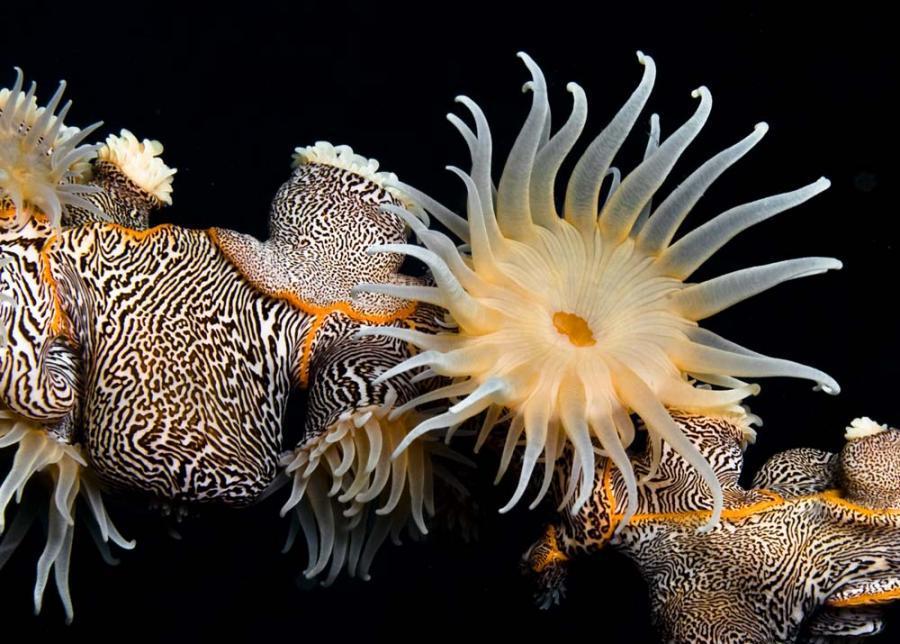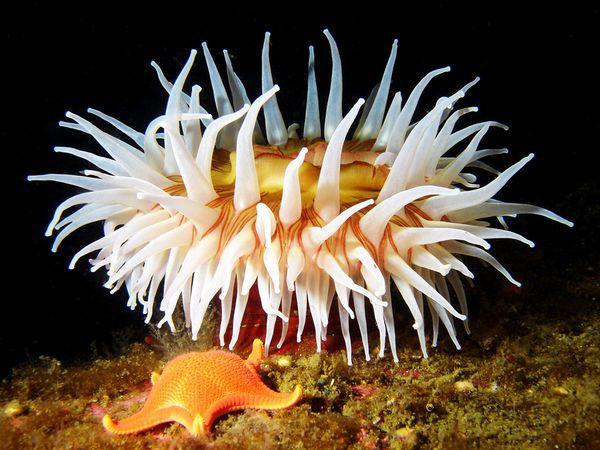The first image is the image on the left, the second image is the image on the right. Evaluate the accuracy of this statement regarding the images: "An anemone image includes a black-and-white almost zebra-like pattern.". Is it true? Answer yes or no. Yes. 